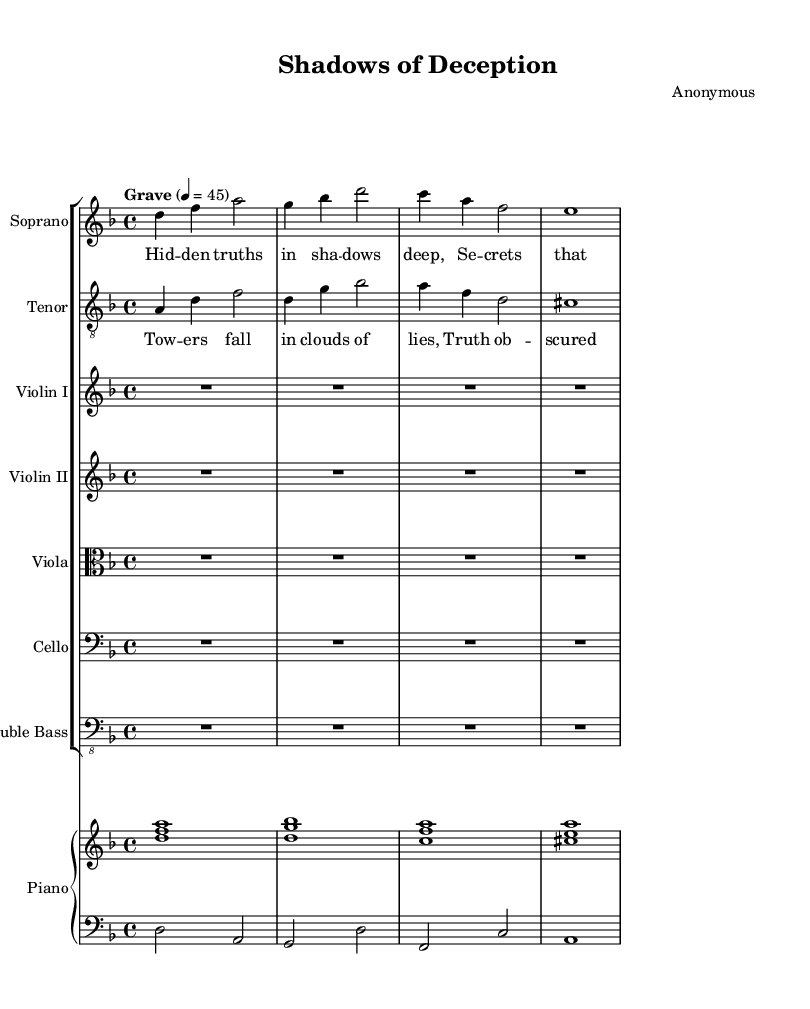What is the key signature of this music? The key signature is indicated at the beginning of the music. In this case, it shows two flat symbols, which corresponds to the key of D minor.
Answer: D minor What is the time signature of this music? The time signature is found at the beginning and shows 4/4, indicating there are four beats in a measure and the quarter note gets one beat.
Answer: 4/4 What is the tempo marking of this piece? The tempo marking states "Grave" with a metronome marking of 4 = 45, meaning the piece should be played very slowly at 45 beats per minute.
Answer: Grave How many instruments are included in this score? The score lists different staves for multiple instruments, including soprano, tenor, violin I, violin II, viola, cello, double bass, and piano, totaling eight instrumental parts.
Answer: Eight What is the dynamic marking at the beginning of the soprano part? The dynamic marking at the beginning of the soprano part is "pp" (pianissimo), indicating it should be played very softly.
Answer: pp What lyrics accompany the soprano part? The lyrics provided under the soprano staff begin with "Hidden truths in shadows deep," conveying themes of secrecy and deception.
Answer: Hidden truths in shadows deep Which voice part has the lyric "Towers fall in clouds of lies"? This lyric is found in the tenor part, indicating a focus on the dramatic theme of deception and cover-up associated with tragic events.
Answer: Tenor 